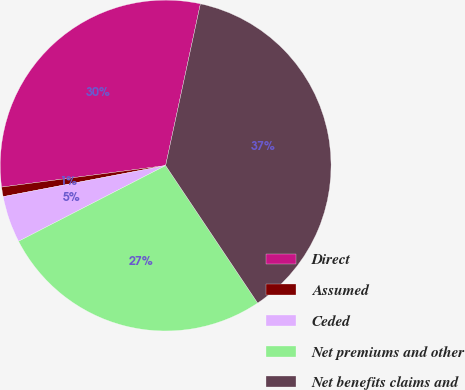<chart> <loc_0><loc_0><loc_500><loc_500><pie_chart><fcel>Direct<fcel>Assumed<fcel>Ceded<fcel>Net premiums and other<fcel>Net benefits claims and<nl><fcel>30.45%<fcel>0.93%<fcel>4.56%<fcel>26.82%<fcel>37.24%<nl></chart> 